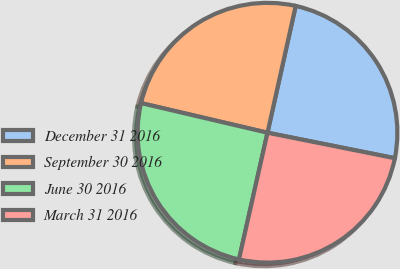<chart> <loc_0><loc_0><loc_500><loc_500><pie_chart><fcel>December 31 2016<fcel>September 30 2016<fcel>June 30 2016<fcel>March 31 2016<nl><fcel>24.66%<fcel>24.82%<fcel>25.14%<fcel>25.38%<nl></chart> 